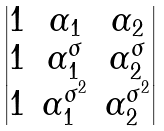Convert formula to latex. <formula><loc_0><loc_0><loc_500><loc_500>\begin{vmatrix} 1 & \alpha _ { 1 } & \alpha _ { 2 } \\ 1 & \alpha _ { 1 } ^ { \sigma } & \alpha _ { 2 } ^ { \sigma } \\ 1 & \alpha _ { 1 } ^ { \sigma ^ { 2 } } & \alpha _ { 2 } ^ { \sigma ^ { 2 } } \end{vmatrix}</formula> 